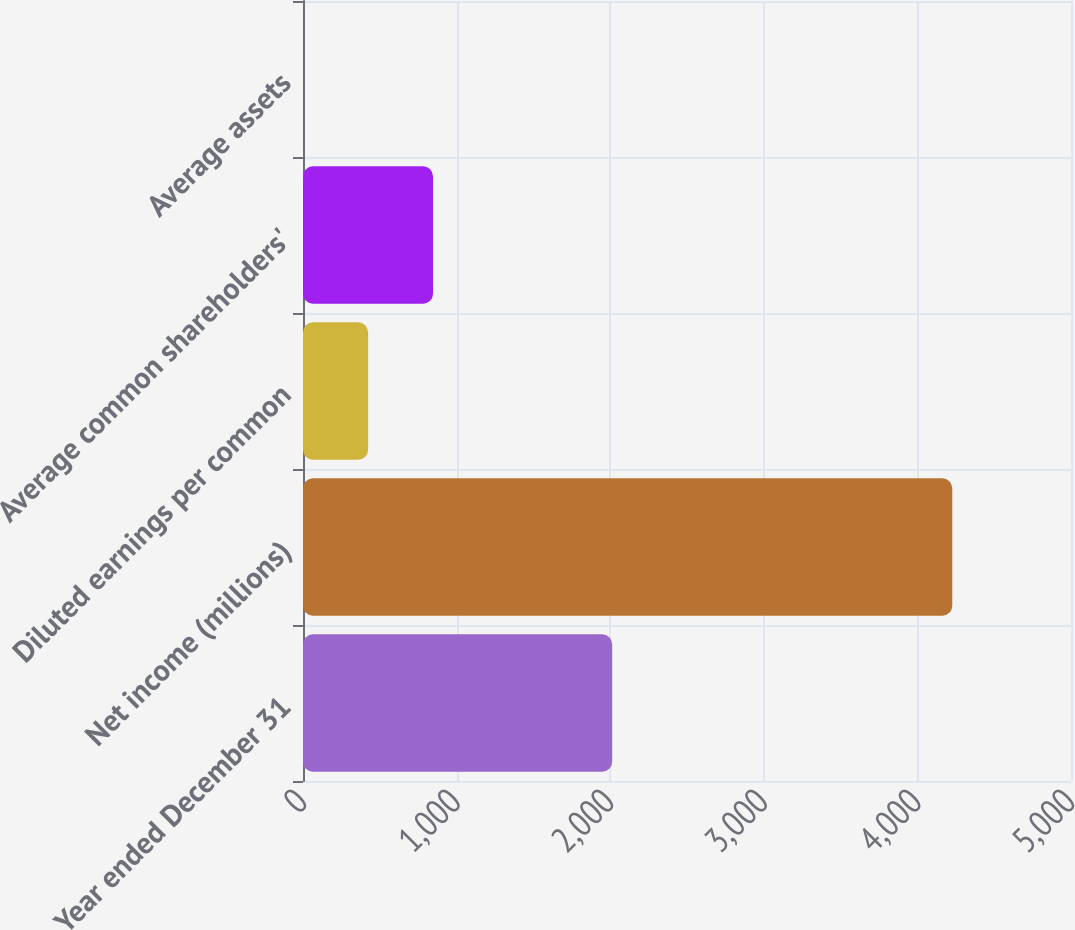Convert chart to OTSL. <chart><loc_0><loc_0><loc_500><loc_500><bar_chart><fcel>Year ended December 31<fcel>Net income (millions)<fcel>Diluted earnings per common<fcel>Average common shareholders'<fcel>Average assets<nl><fcel>2013<fcel>4227<fcel>423.94<fcel>846.5<fcel>1.38<nl></chart> 